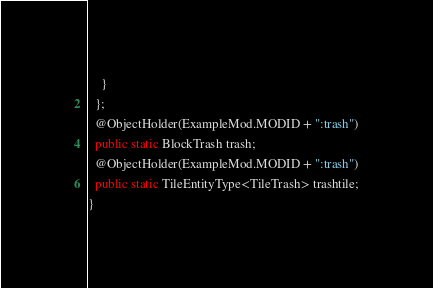Convert code to text. <code><loc_0><loc_0><loc_500><loc_500><_Java_>    }
  };
  @ObjectHolder(ExampleMod.MODID + ":trash")
  public static BlockTrash trash;
  @ObjectHolder(ExampleMod.MODID + ":trash")
  public static TileEntityType<TileTrash> trashtile;
}
</code> 